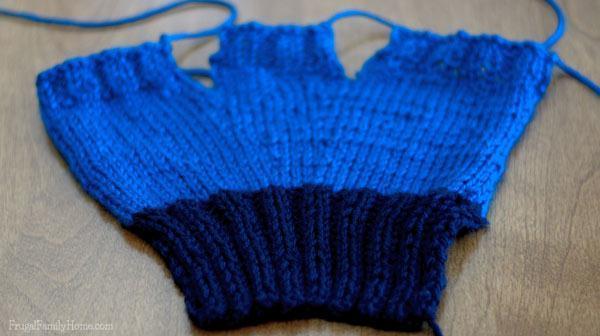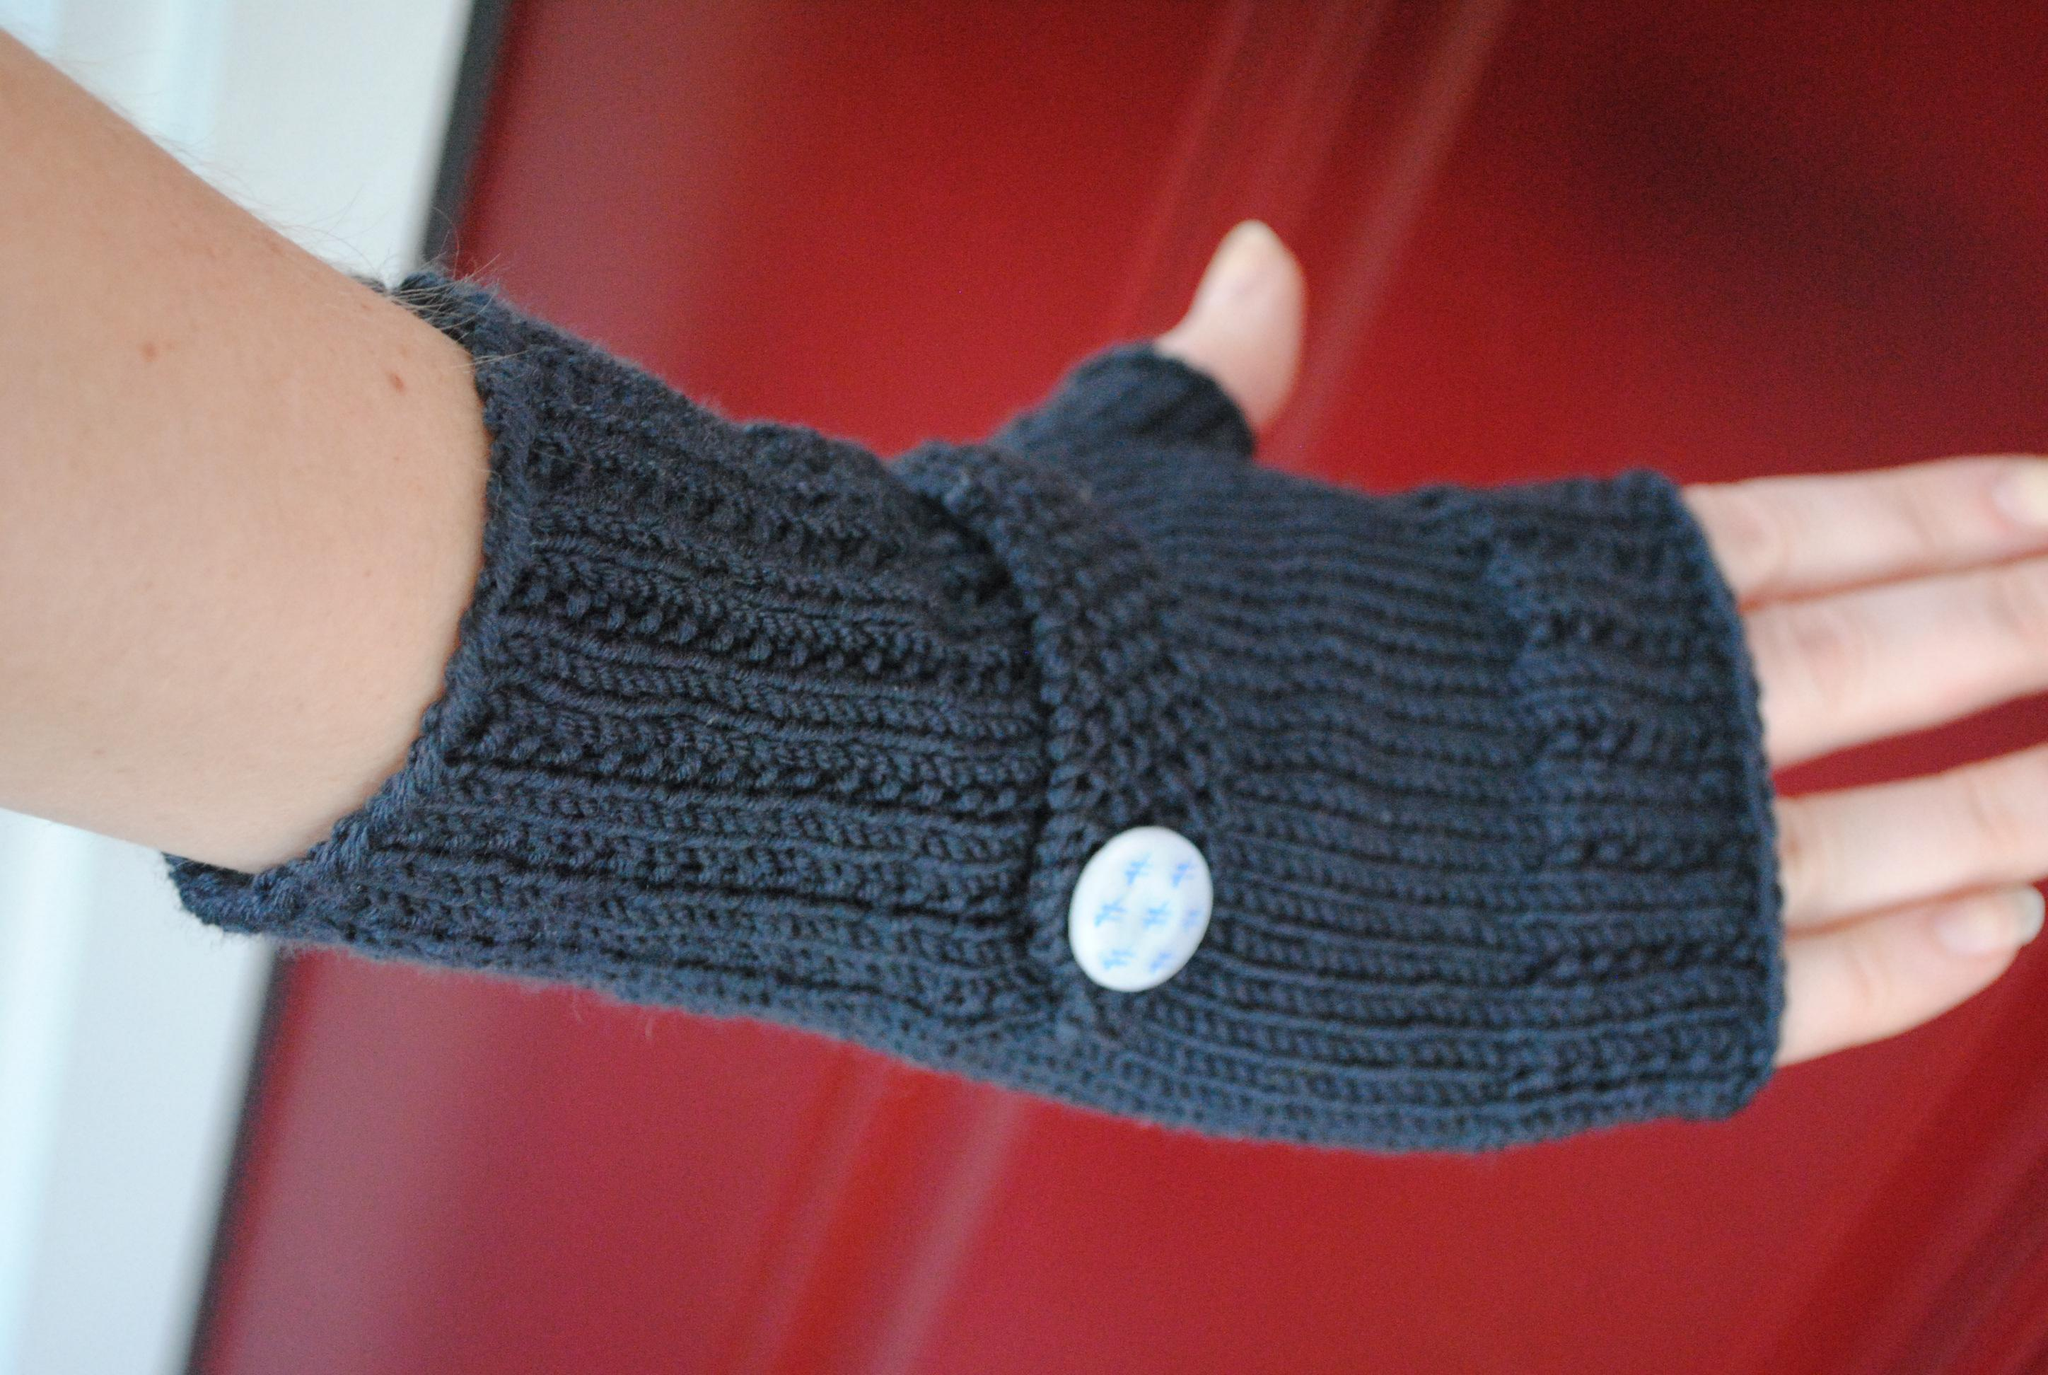The first image is the image on the left, the second image is the image on the right. For the images shown, is this caption "Both images feature a soild-colored fingerless yarn mitten modeled by a human hand." true? Answer yes or no. No. The first image is the image on the left, the second image is the image on the right. Considering the images on both sides, is "In one image there is exactly one human hand modeling a fingerless glove." valid? Answer yes or no. Yes. 